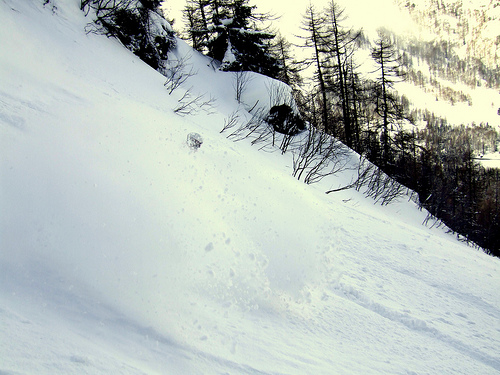<image>
Is the trees above the snow? No. The trees is not positioned above the snow. The vertical arrangement shows a different relationship. 